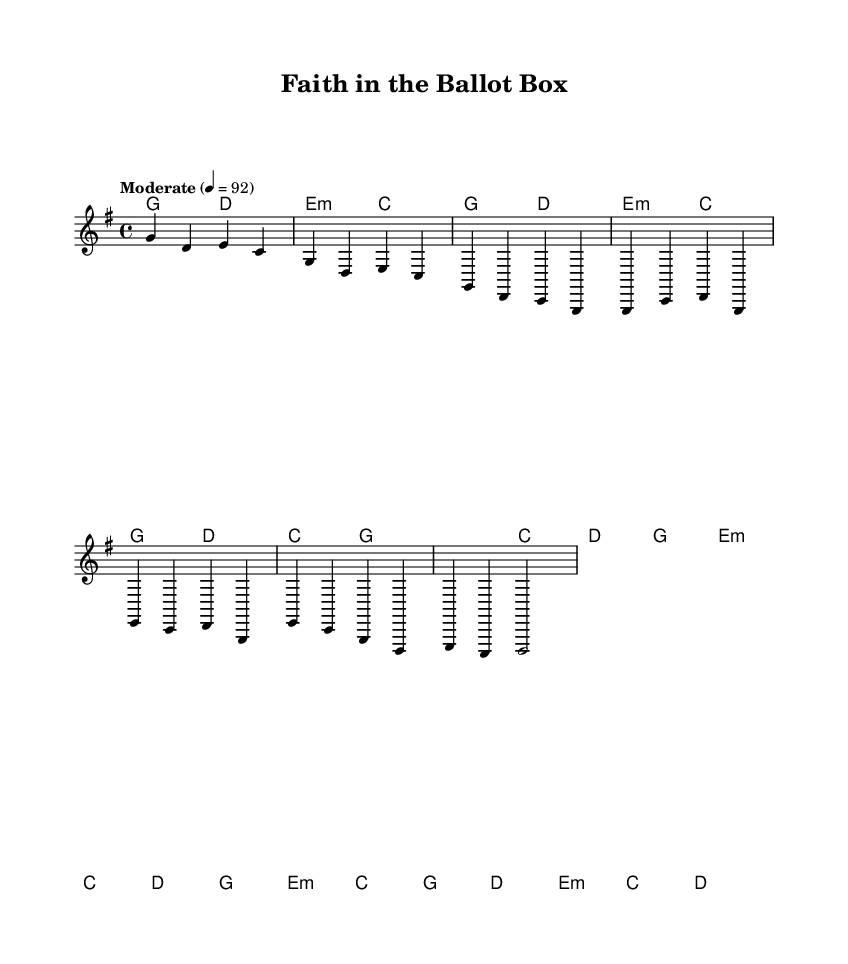What is the key signature of this music? The key signature is G major, which has one sharp (F#). This can be deduced from the `\key g \major` instruction at the beginning of the music code.
Answer: G major What is the time signature of this music? The time signature is 4/4, which indicates that there are four beats in each measure, and the quarter note gets one beat. This is specified in the `\time 4/4` part of the code.
Answer: 4/4 What is the tempo marking for this piece? The tempo marking is "Moderate" at a speed of 92 beats per minute, as indicated by the `\tempo "Moderate" 4 = 92` line in the code.
Answer: Moderate, 92 How many measures are there in the chorus? There are four measures in the chorus, as the section consists of four distinct musical phrases, each written with a vertical line representing the end of a measure.
Answer: 4 What chord type is used in the bridge section? The bridge section includes minor chords, specifically the E minor chord, as indicated by `e2:m` in the harmonies, which denotes the use of the minor seventh.
Answer: Minor What is the last chord played in this piece? The last chord played is D major, which is indicated by the `d1` at the end of the bridge section in the harmonies. This closure suggests a resolution characteristic in country music.
Answer: D major 